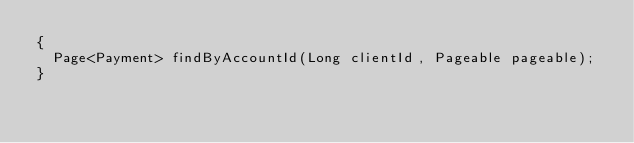Convert code to text. <code><loc_0><loc_0><loc_500><loc_500><_Java_>{
  Page<Payment> findByAccountId(Long clientId, Pageable pageable);
}
</code> 